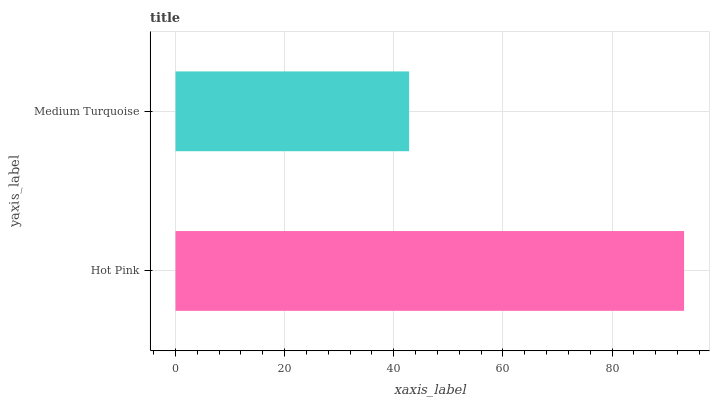Is Medium Turquoise the minimum?
Answer yes or no. Yes. Is Hot Pink the maximum?
Answer yes or no. Yes. Is Medium Turquoise the maximum?
Answer yes or no. No. Is Hot Pink greater than Medium Turquoise?
Answer yes or no. Yes. Is Medium Turquoise less than Hot Pink?
Answer yes or no. Yes. Is Medium Turquoise greater than Hot Pink?
Answer yes or no. No. Is Hot Pink less than Medium Turquoise?
Answer yes or no. No. Is Hot Pink the high median?
Answer yes or no. Yes. Is Medium Turquoise the low median?
Answer yes or no. Yes. Is Medium Turquoise the high median?
Answer yes or no. No. Is Hot Pink the low median?
Answer yes or no. No. 